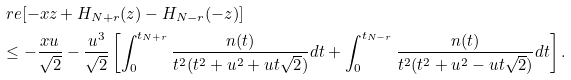Convert formula to latex. <formula><loc_0><loc_0><loc_500><loc_500>& \ r e [ - x z + H _ { N + r } ( z ) - H _ { N - r } ( - z ) ] \\ & \leq - \frac { x u } { \sqrt { 2 } } - \frac { u ^ { 3 } } { \sqrt { 2 } } \left [ \int _ { 0 } ^ { t _ { N + r } } \frac { n ( t ) } { t ^ { 2 } ( t ^ { 2 } + u ^ { 2 } + u t \sqrt { 2 } ) } d t + \int _ { 0 } ^ { t _ { N - r } } \frac { n ( t ) } { t ^ { 2 } ( t ^ { 2 } + u ^ { 2 } - u t \sqrt { 2 } ) } d t \right ] .</formula> 